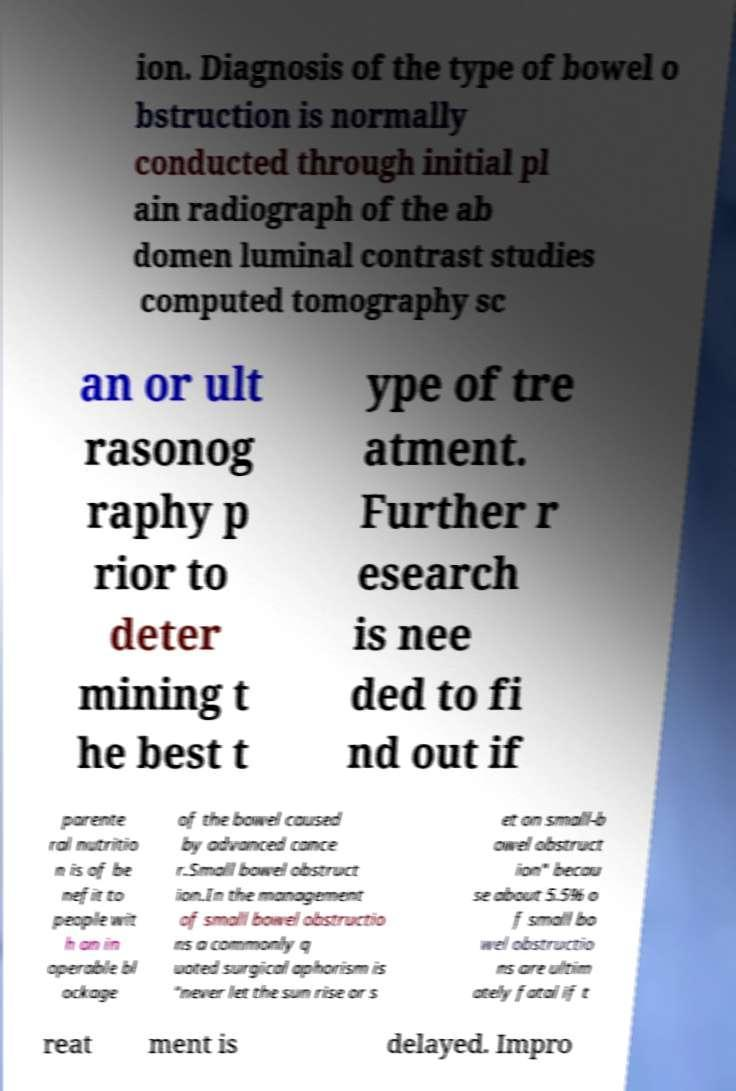For documentation purposes, I need the text within this image transcribed. Could you provide that? ion. Diagnosis of the type of bowel o bstruction is normally conducted through initial pl ain radiograph of the ab domen luminal contrast studies computed tomography sc an or ult rasonog raphy p rior to deter mining t he best t ype of tre atment. Further r esearch is nee ded to fi nd out if parente ral nutritio n is of be nefit to people wit h an in operable bl ockage of the bowel caused by advanced cance r.Small bowel obstruct ion.In the management of small bowel obstructio ns a commonly q uoted surgical aphorism is "never let the sun rise or s et on small-b owel obstruct ion" becau se about 5.5% o f small bo wel obstructio ns are ultim ately fatal if t reat ment is delayed. Impro 